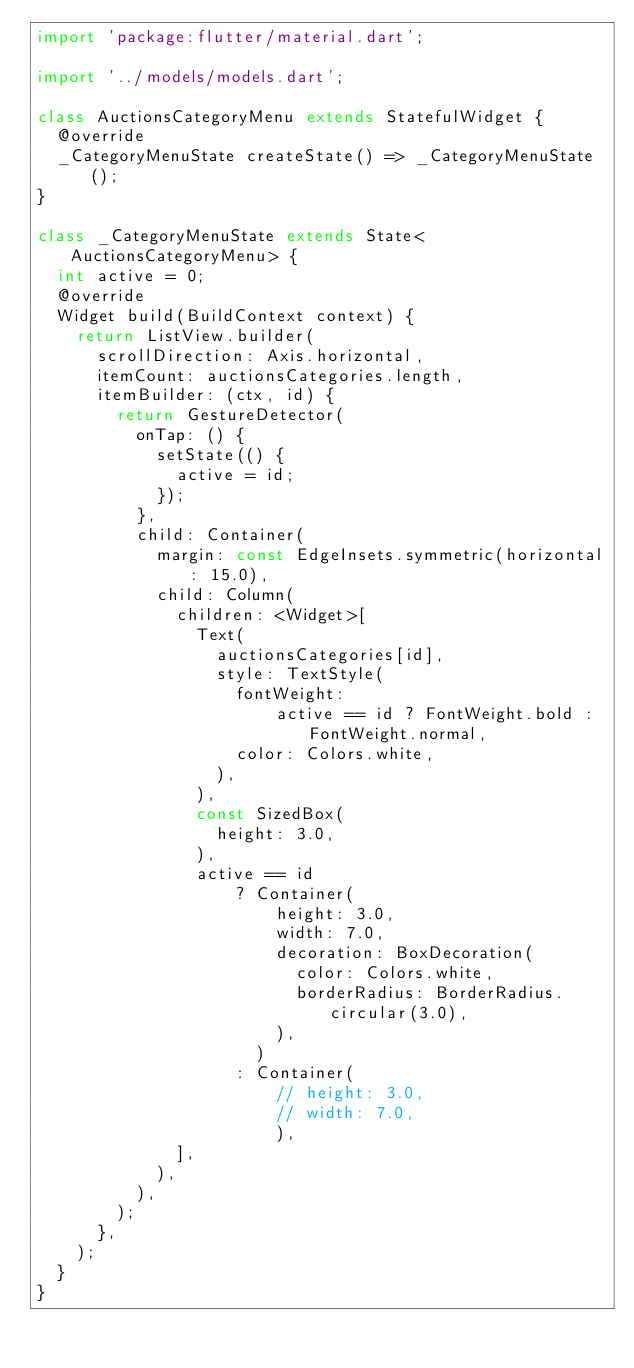Convert code to text. <code><loc_0><loc_0><loc_500><loc_500><_Dart_>import 'package:flutter/material.dart';

import '../models/models.dart';

class AuctionsCategoryMenu extends StatefulWidget {
  @override
  _CategoryMenuState createState() => _CategoryMenuState();
}

class _CategoryMenuState extends State<AuctionsCategoryMenu> {
  int active = 0;
  @override
  Widget build(BuildContext context) {
    return ListView.builder(
      scrollDirection: Axis.horizontal,
      itemCount: auctionsCategories.length,
      itemBuilder: (ctx, id) {
        return GestureDetector(
          onTap: () {
            setState(() {
              active = id;
            });
          },
          child: Container(
            margin: const EdgeInsets.symmetric(horizontal: 15.0),
            child: Column(
              children: <Widget>[
                Text(
                  auctionsCategories[id],
                  style: TextStyle(
                    fontWeight:
                        active == id ? FontWeight.bold : FontWeight.normal,
                    color: Colors.white,
                  ),
                ),
                const SizedBox(
                  height: 3.0,
                ),
                active == id
                    ? Container(
                        height: 3.0,
                        width: 7.0,
                        decoration: BoxDecoration(
                          color: Colors.white,
                          borderRadius: BorderRadius.circular(3.0),
                        ),
                      )
                    : Container(
                        // height: 3.0,
                        // width: 7.0,
                        ),
              ],
            ),
          ),
        );
      },
    );
  }
}
</code> 